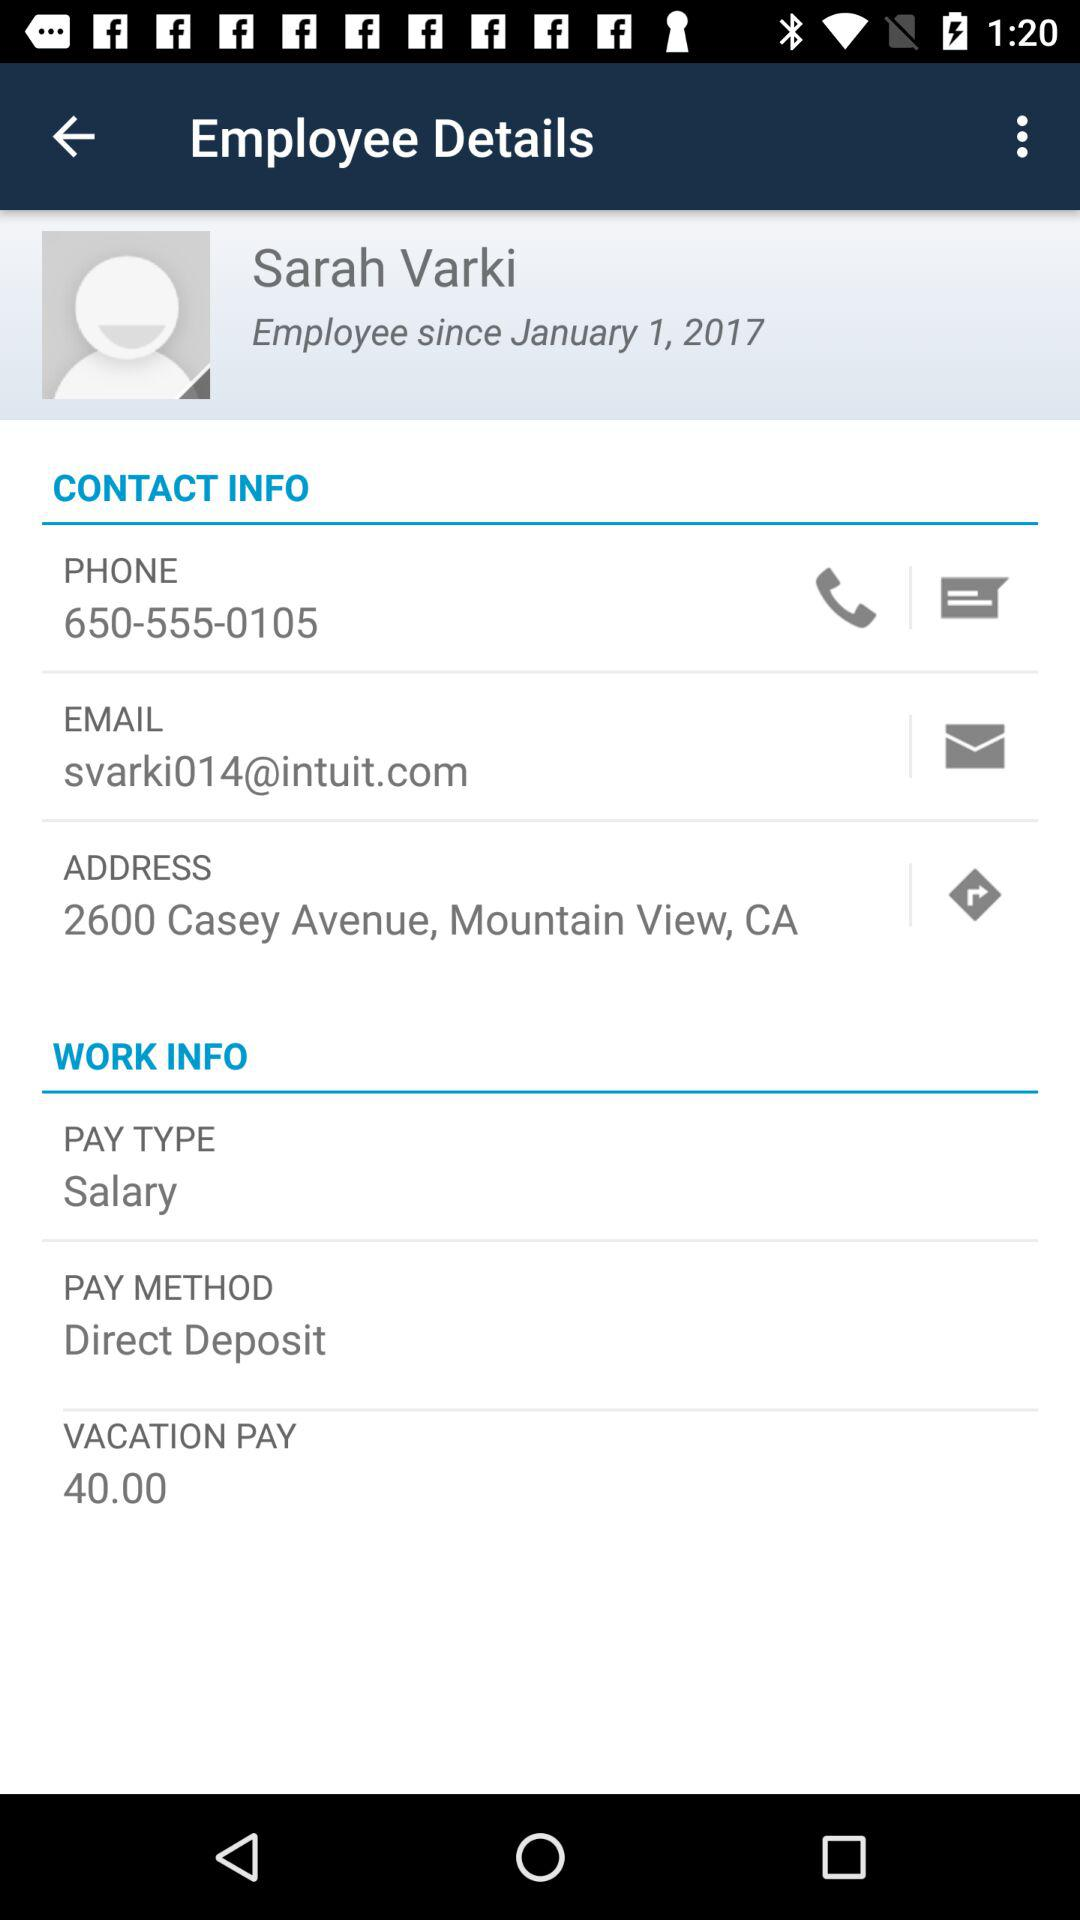What is the joining date of the employee? The joining date of the employee is January 1, 2017. 